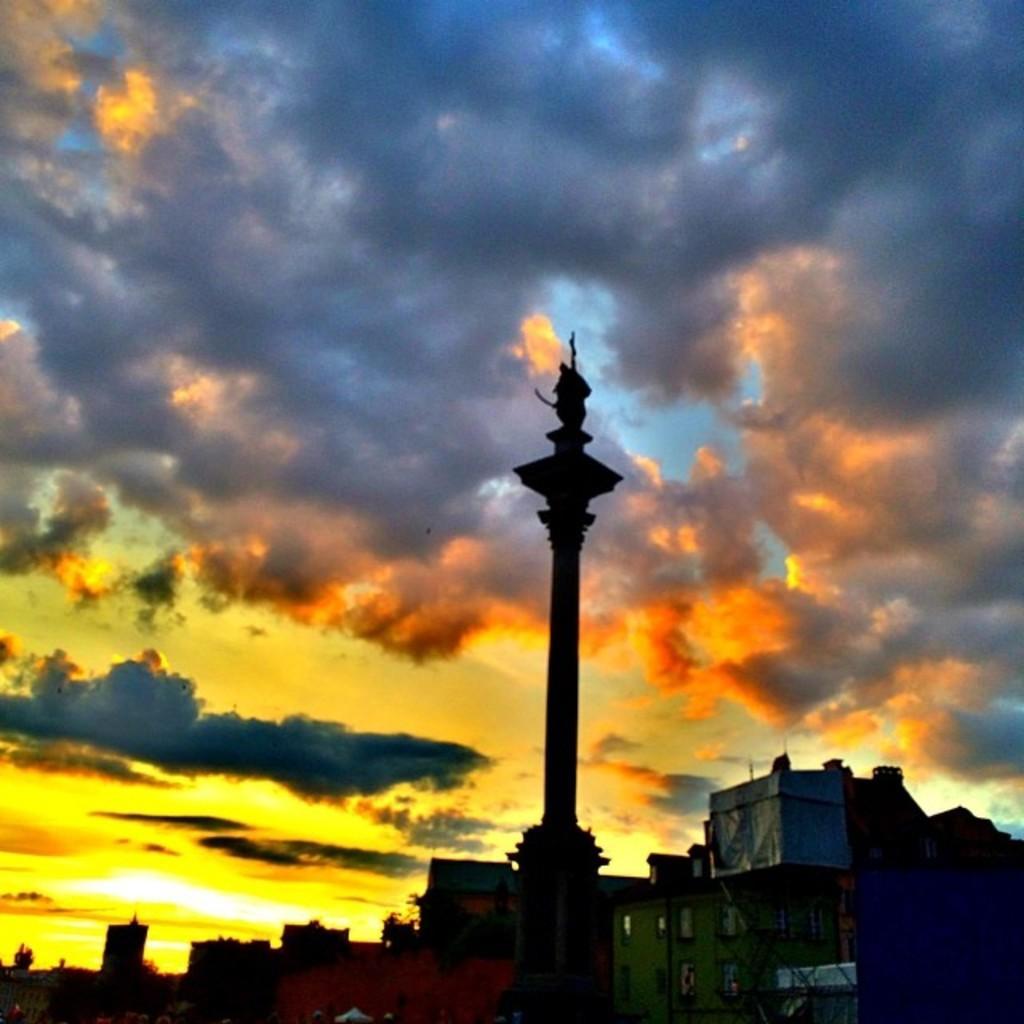Could you give a brief overview of what you see in this image? In this image we can see a pole, houses, at the top we can see the sky with clouds. 